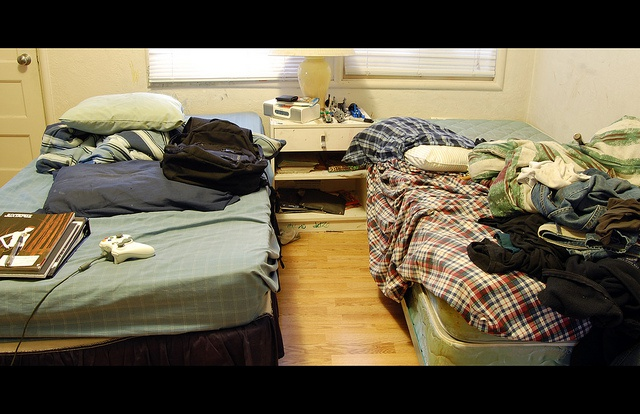Describe the objects in this image and their specific colors. I can see bed in black, gray, darkgray, and darkgreen tones, bed in black, olive, and gray tones, backpack in black and gray tones, book in black, olive, ivory, and gray tones, and bed in black, darkgray, beige, tan, and gray tones in this image. 